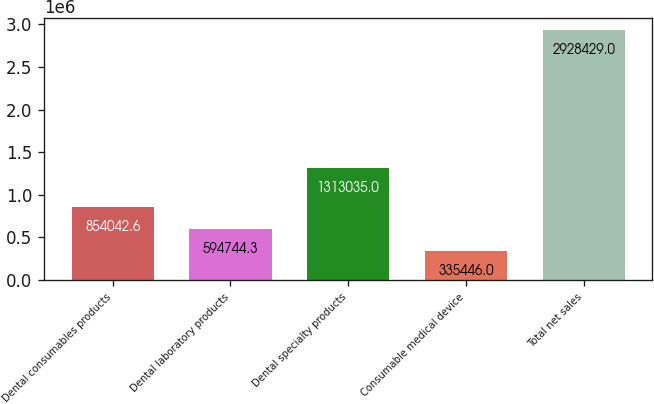Convert chart to OTSL. <chart><loc_0><loc_0><loc_500><loc_500><bar_chart><fcel>Dental consumables products<fcel>Dental laboratory products<fcel>Dental specialty products<fcel>Consumable medical device<fcel>Total net sales<nl><fcel>854043<fcel>594744<fcel>1.31304e+06<fcel>335446<fcel>2.92843e+06<nl></chart> 